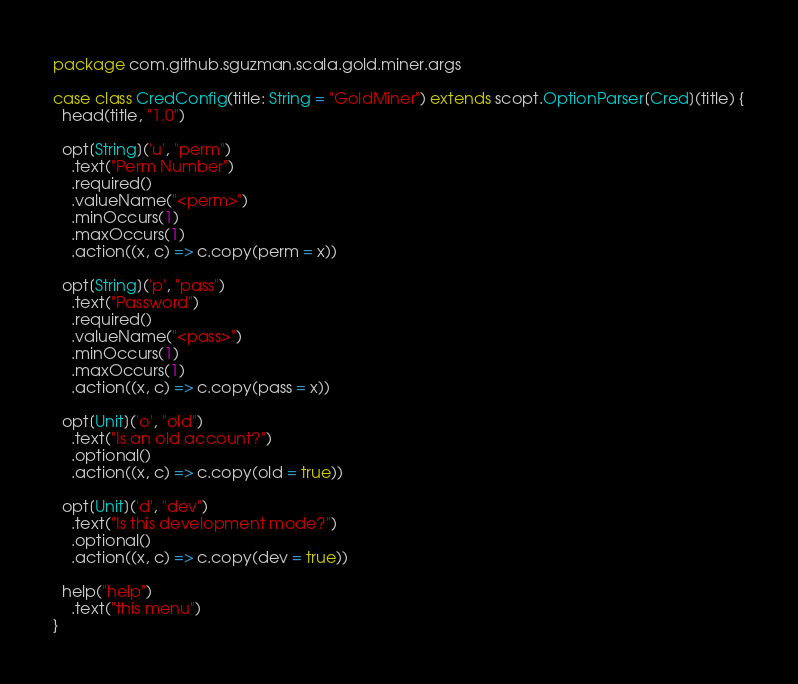Convert code to text. <code><loc_0><loc_0><loc_500><loc_500><_Scala_>package com.github.sguzman.scala.gold.miner.args

case class CredConfig(title: String = "GoldMiner") extends scopt.OptionParser[Cred](title) {
  head(title, "1.0")

  opt[String]('u', "perm")
    .text("Perm Number")
    .required()
    .valueName("<perm>")
    .minOccurs(1)
    .maxOccurs(1)
    .action((x, c) => c.copy(perm = x))

  opt[String]('p', "pass")
    .text("Password")
    .required()
    .valueName("<pass>")
    .minOccurs(1)
    .maxOccurs(1)
    .action((x, c) => c.copy(pass = x))

  opt[Unit]('o', "old")
    .text("Is an old account?")
    .optional()
    .action((x, c) => c.copy(old = true))

  opt[Unit]('d', "dev")
    .text("Is this development mode?")
    .optional()
    .action((x, c) => c.copy(dev = true))

  help("help")
    .text("this menu")
}</code> 